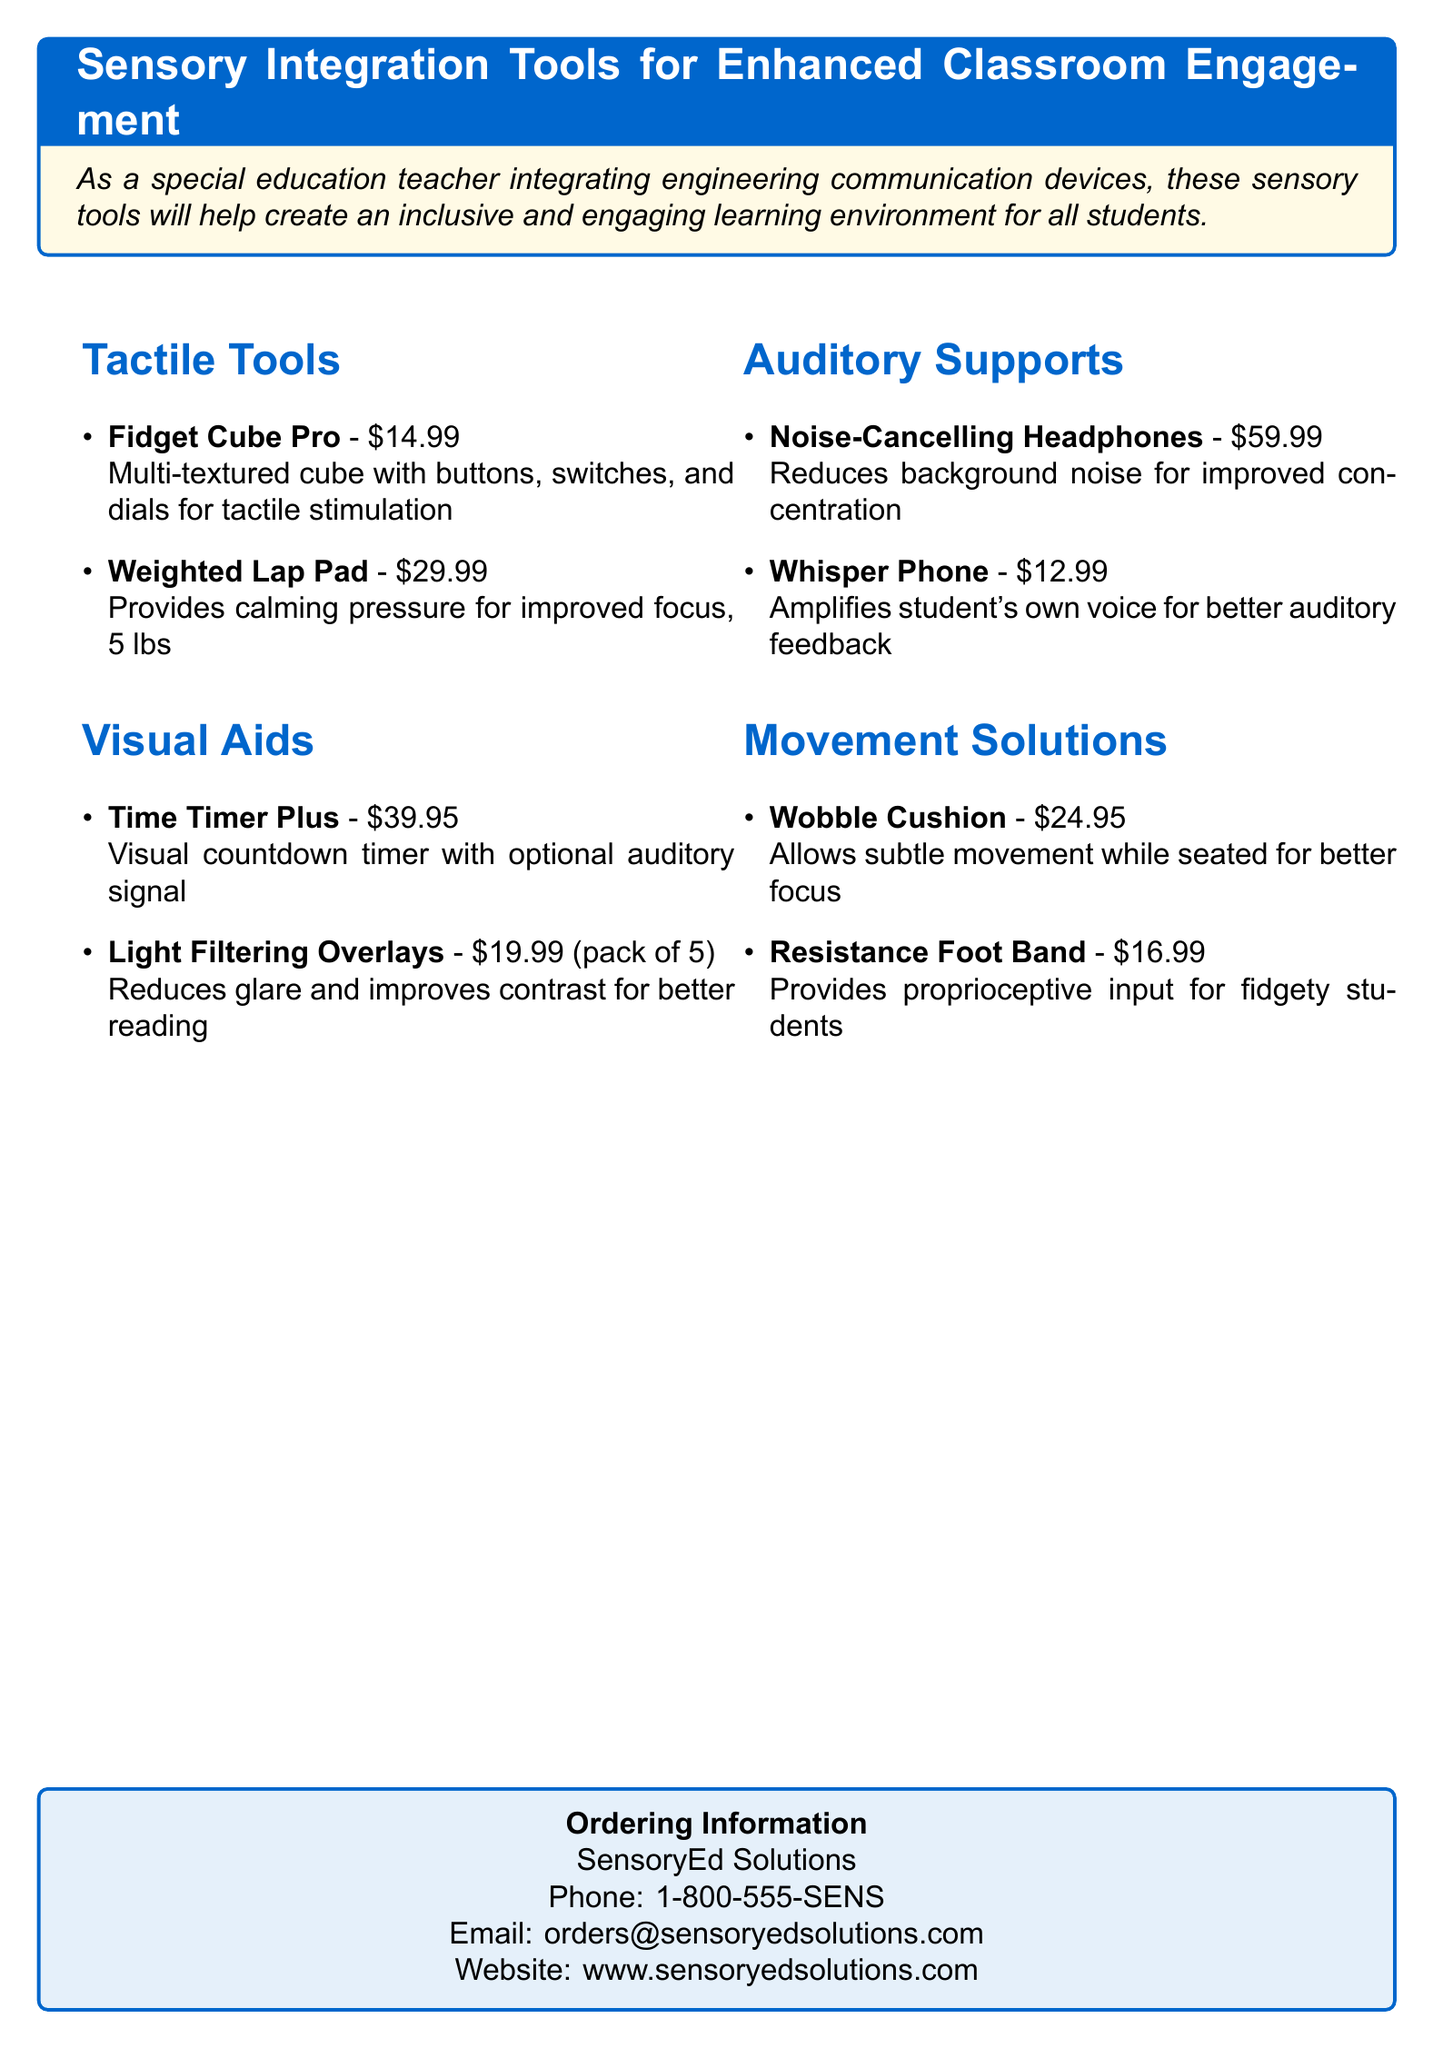What is the price of the Fidget Cube Pro? The price of the Fidget Cube Pro is mentioned under the Tactile Tools section of the document.
Answer: $14.99 What are the two types of auditory supports listed? The document provides specific items under the Auditory Supports section, which includes Noise-Cancelling Headphones and Whisper Phone.
Answer: Noise-Cancelling Headphones, Whisper Phone How much does the Weighted Lap Pad weigh? The weight of the Weighted Lap Pad is specified in the description under Tactile Tools.
Answer: 5 lbs What is the price for a pack of Light Filtering Overlays? The price for Light Filtering Overlays is mentioned in the Visual Aids section, which describes it as a pack of 5.
Answer: $19.99 Which product provides proprioceptive input for fidgety students? The information is provided within the Movement Solutions section that lists various products, indicating which ones serve this function.
Answer: Resistance Foot Band How many items are listed under Tactile Tools? The total number of items in the Tactile Tools section can be determined by counting the items listed there.
Answer: 2 Which company can be contacted for ordering information? The ordering information section provides the name of the company.
Answer: SensoryEd Solutions What feature does the Time Timer Plus offer? This feature is described in the Visual Aids section, highlighting its functionality.
Answer: Visual countdown timer with optional auditory signal What type of tool is the Wobble Cushion? The Wobble Cushion is categorized under Movement Solutions, which defines its purpose in the classroom setting.
Answer: Movement solution 